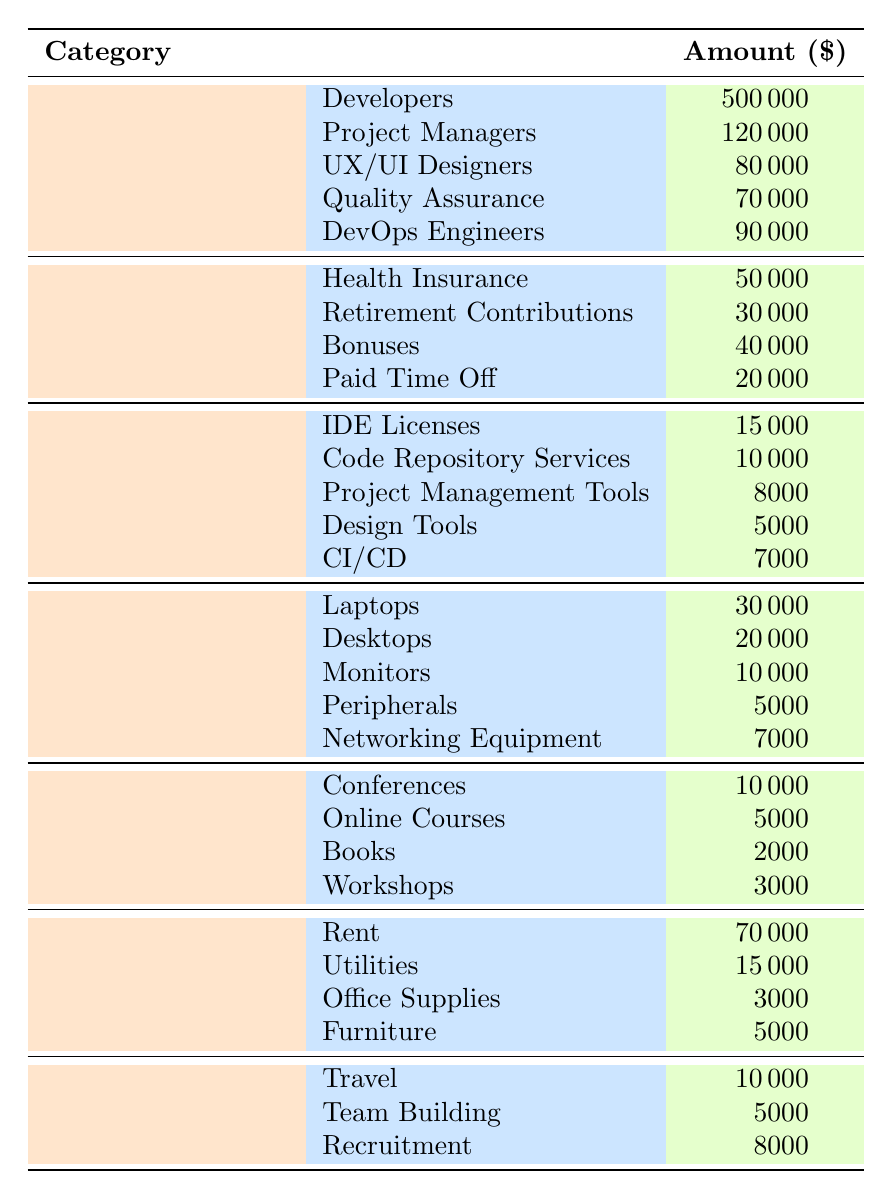What is the total amount allocated to Salaries? To find the total amount allocated to Salaries, we need to sum all the individual amounts under the Salaries category: 500000 (Developers) + 120000 (Project Managers) + 80000 (UX/UI Designers) + 70000 (Quality Assurance) + 90000 (DevOps Engineers) = 860000.
Answer: 860000 How much is spent on Benefits in total? The total amount for Benefits can be calculated by summing all the individual benefit expenses: 50000 (Health Insurance) + 30000 (Retirement Contributions) + 40000 (Bonuses) + 20000 (Paid Time Off) = 140000.
Answer: 140000 Is the expense for Software Licenses greater than the expense for Training? The total for Software Licenses is 15000 + 10000 + 8000 + 5000 + 7000 = 46000. The total for Training is 10000 + 5000 + 2000 + 3000 = 20000. Since 46000 is greater than 20000, the statement is true.
Answer: Yes What category has the highest individual expense and what is its value? To find the highest individual expense, we need to compare all the individual expenses across categories. The maximum value is 500000 from the Developers under Salaries.
Answer: 500000 (Developers) What is the total expenditure for Office Space? The total expenditure for Office Space can be calculated by adding all individual costs: 70000 (Rent) + 15000 (Utilities) + 3000 (Office Supplies) + 5000 (Furniture) = 93500.
Answer: 93500 How much more is spent on Salaries than on Training? To calculate this, we need to find the total for both categories: Salaries is 860000 and Training is 20000. The difference is 860000 - 20000 = 840000.
Answer: 840000 In the Hardware category, which item has the lowest cost? From the Hardware category: Laptops (30000), Desktops (20000), Monitors (10000), Peripherals (5000), and Networking Equipment (7000). The lowest cost is 5000 for Peripherals.
Answer: 5000 (Peripherals) Are the total expenses for Miscellaneous more or less than 25000? To determine this, sum the expenses in Miscellaneous: Travel (10000) + Team Building (5000) + Recruitment (8000) = 23000. Since 23000 is less than 25000, the answer is no.
Answer: No 